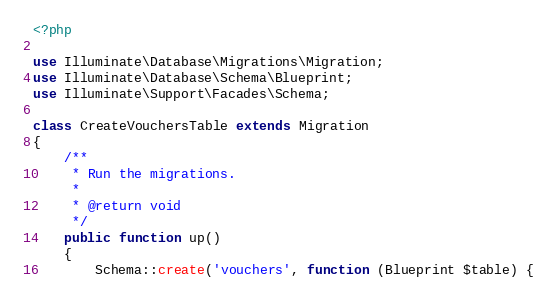<code> <loc_0><loc_0><loc_500><loc_500><_PHP_><?php

use Illuminate\Database\Migrations\Migration;
use Illuminate\Database\Schema\Blueprint;
use Illuminate\Support\Facades\Schema;

class CreateVouchersTable extends Migration
{
    /**
     * Run the migrations.
     *
     * @return void
     */
    public function up()
    {
        Schema::create('vouchers', function (Blueprint $table) {</code> 